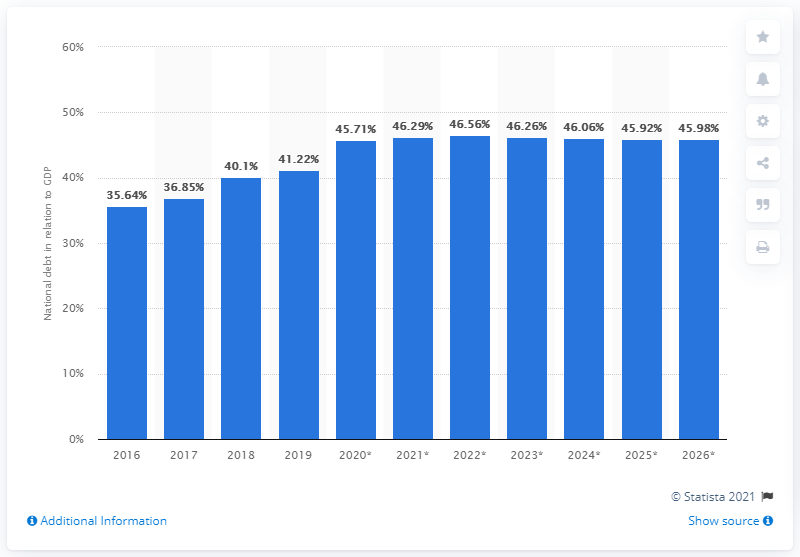Highlight a few significant elements in this photo. In 2019, the national debt of Ivory Coast accounted for 41.22% of the country's Gross Domestic Product (GDP). 